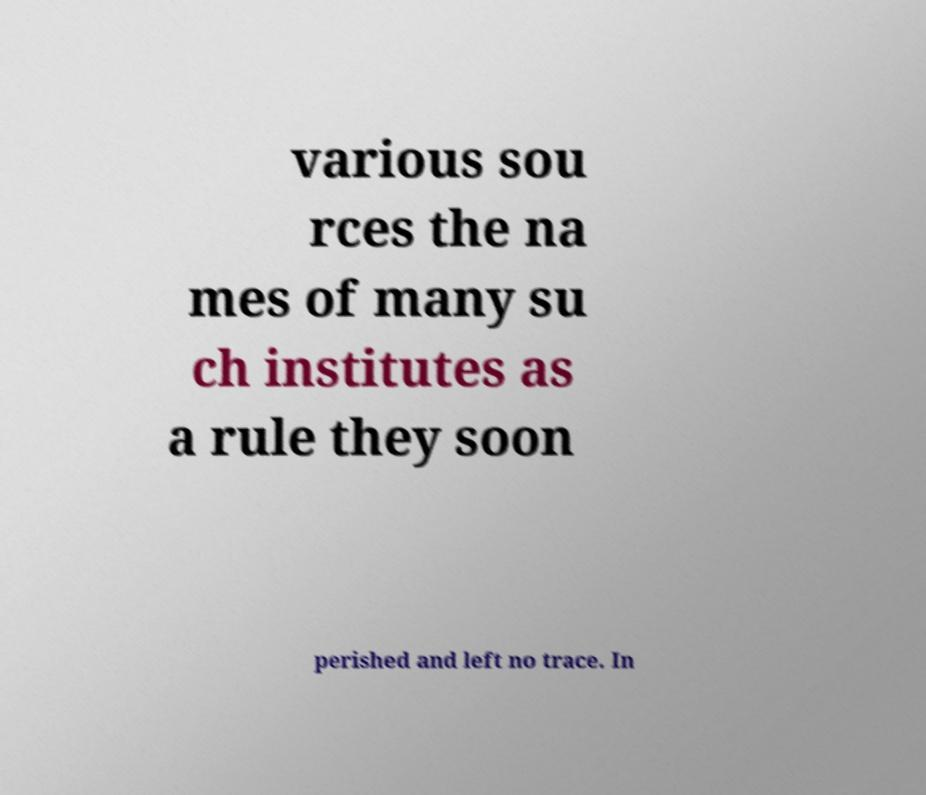I need the written content from this picture converted into text. Can you do that? various sou rces the na mes of many su ch institutes as a rule they soon perished and left no trace. In 